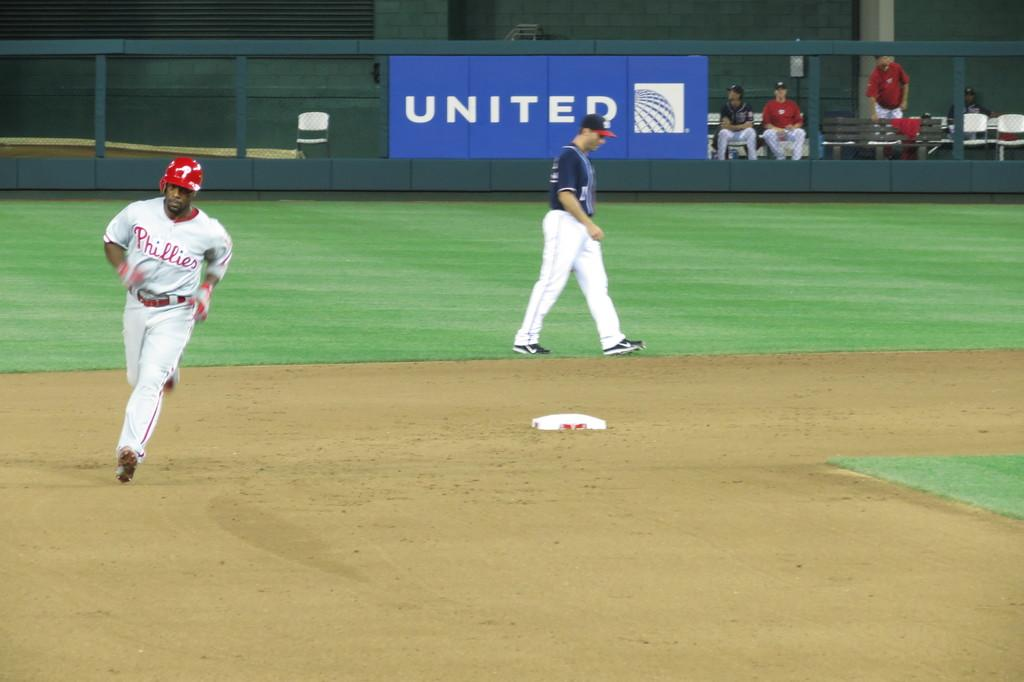<image>
Summarize the visual content of the image. Philadelphi Phillies players runs around the bases quickly 